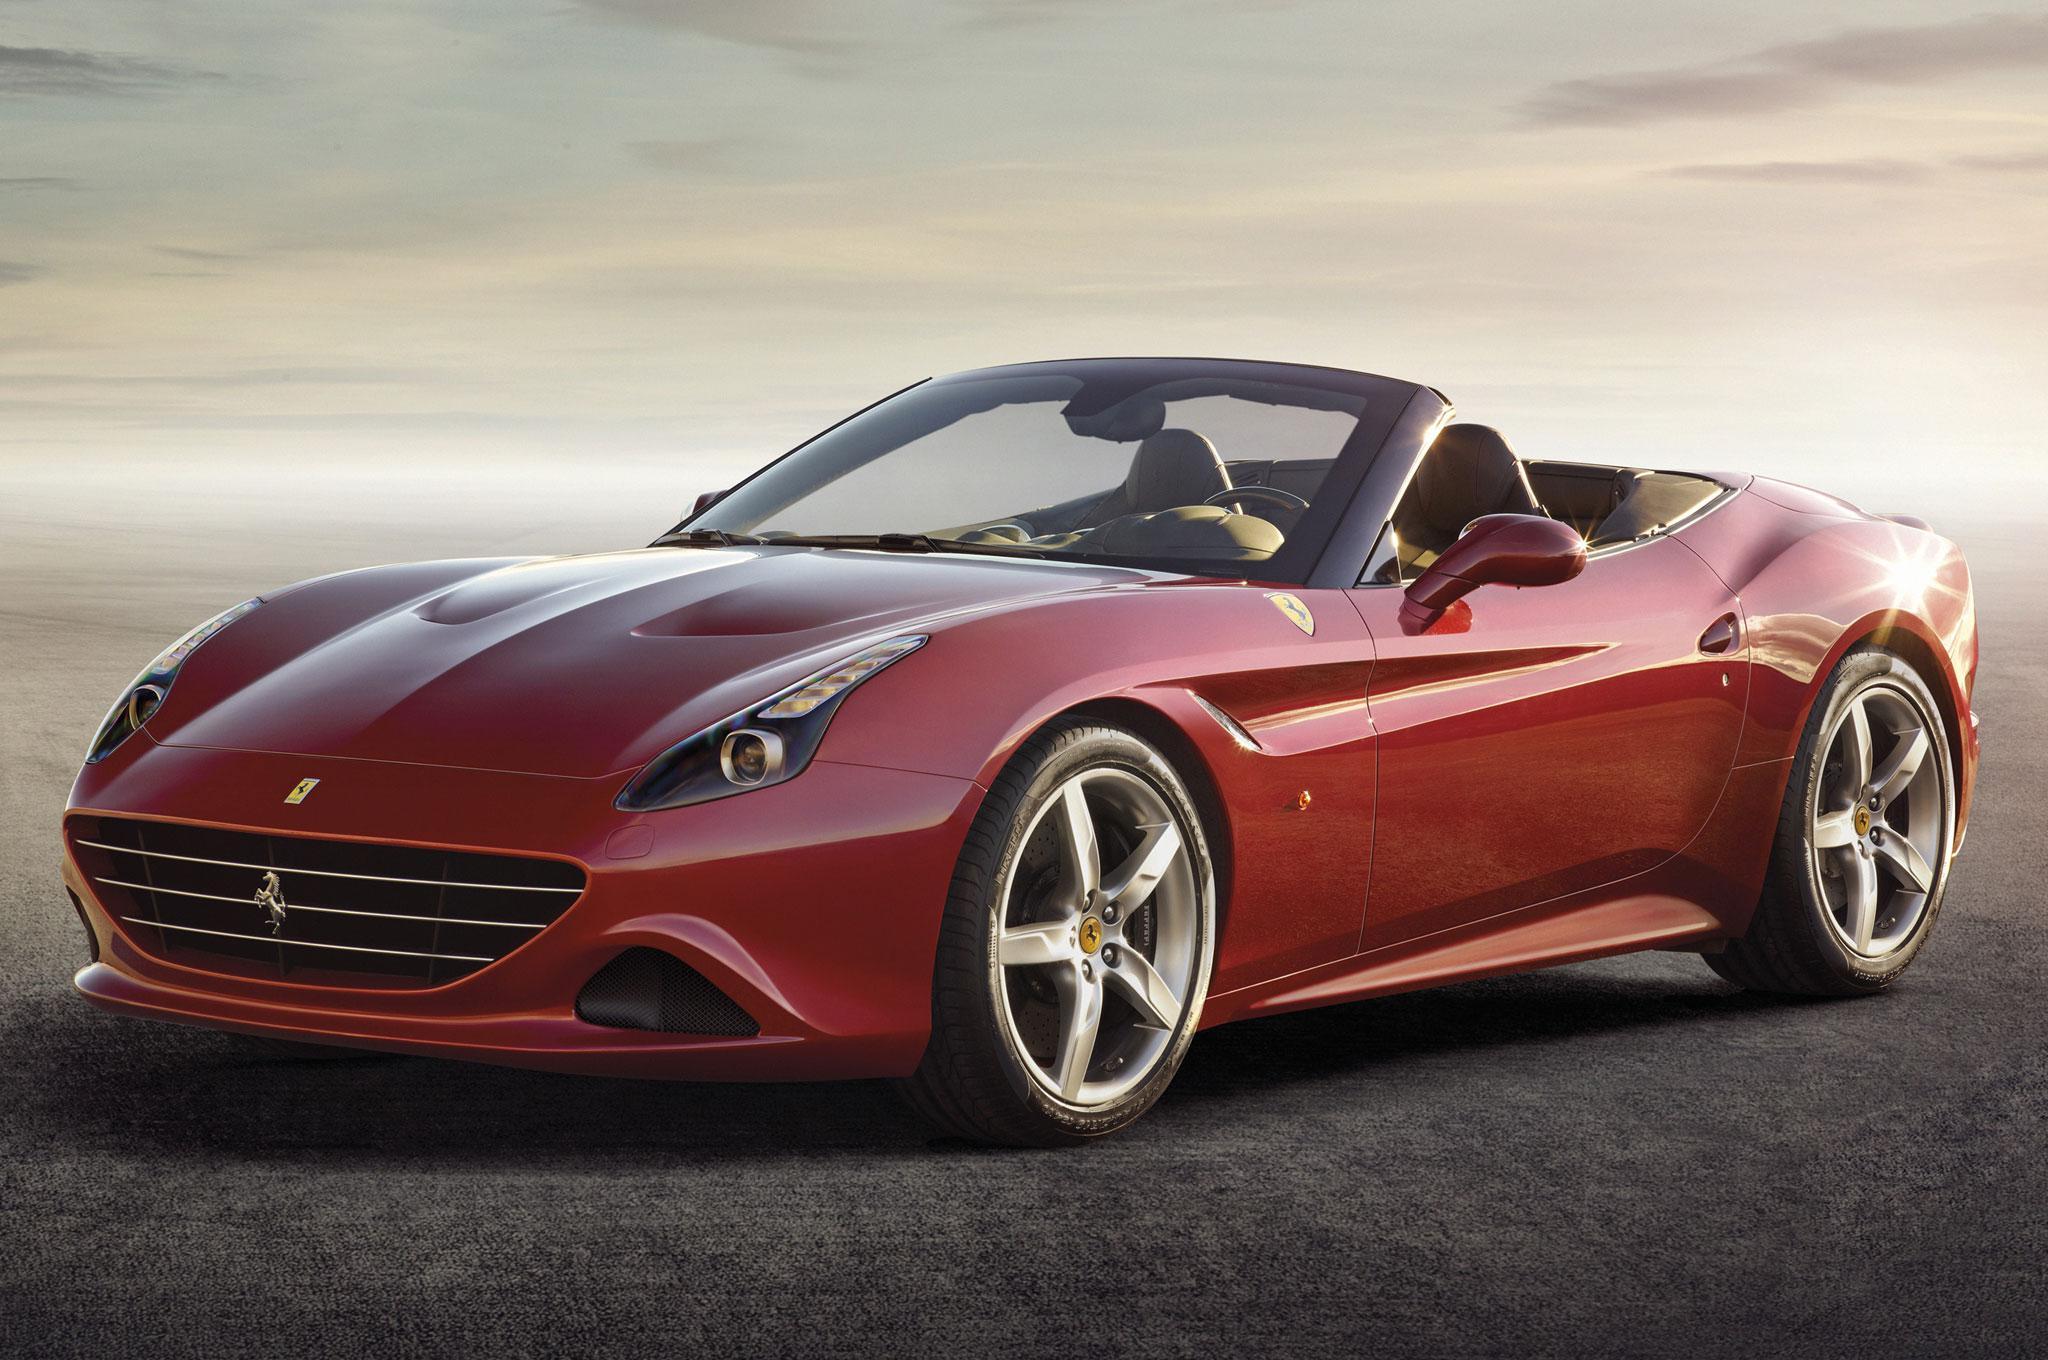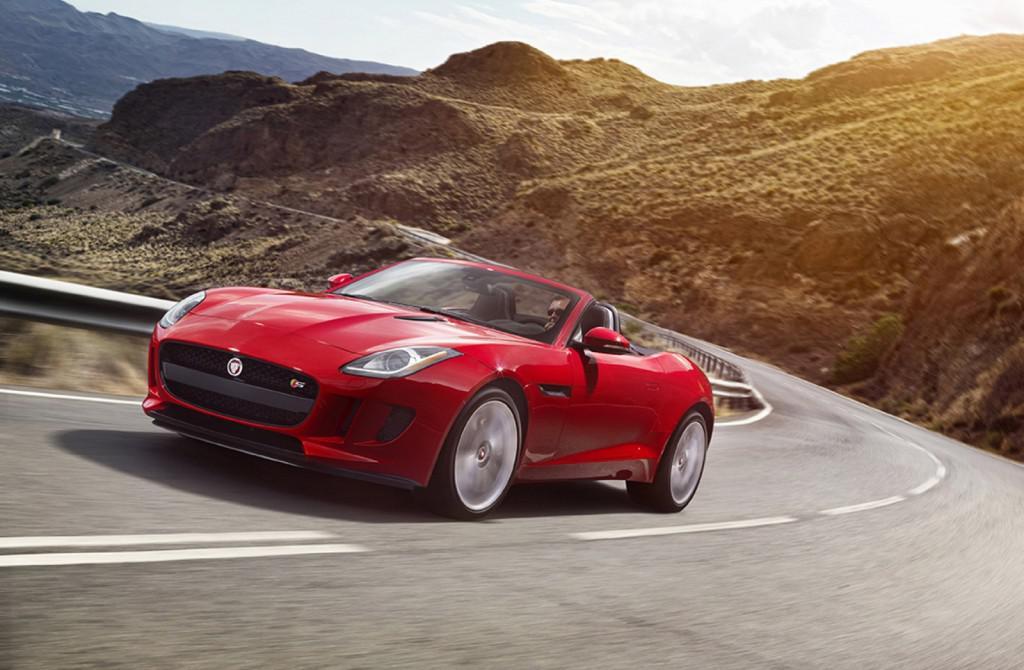The first image is the image on the left, the second image is the image on the right. For the images shown, is this caption "The cars in the left and right images face the same direction, but one has its top up and one has its top down." true? Answer yes or no. No. The first image is the image on the left, the second image is the image on the right. Evaluate the accuracy of this statement regarding the images: "There is one car with its top down and one car with the top up". Is it true? Answer yes or no. No. 